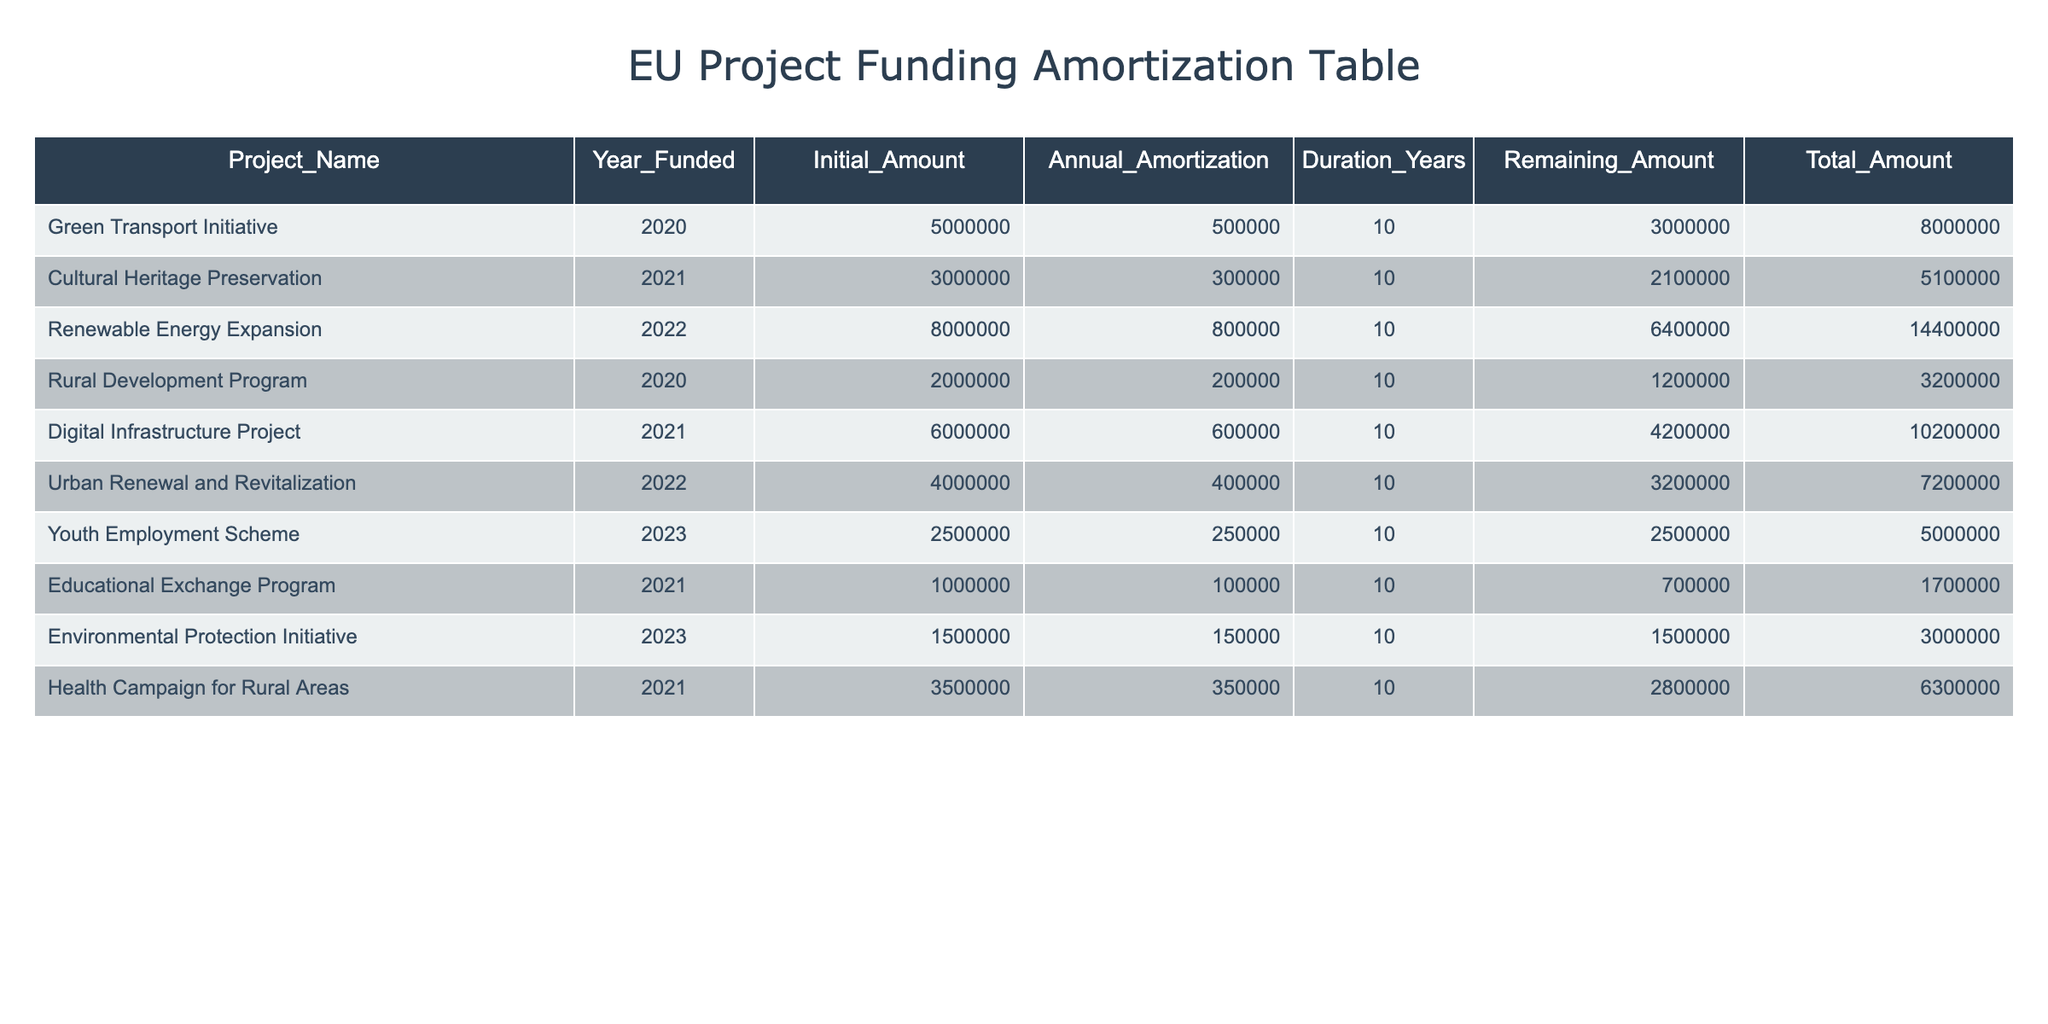What is the remaining amount for the Green Transport Initiative? The remaining amount for each project is listed in the "Remaining_Amount" column. For the Green Transport Initiative, this value is specified as 3000000.
Answer: 3000000 Which project has the highest initial amount? To determine the project with the highest initial amount, I will compare the values in the "Initial_Amount" column. The Renewable Energy Expansion has an initial amount of 8000000, which is higher than all other projects.
Answer: Renewable Energy Expansion How much total funding has been allocated for the Cultural Heritage Preservation? The total funding is calculated by adding the "Initial_Amount" and "Remaining_Amount" for the Cultural Heritage Preservation. The initial amount is 3000000, and the remaining amount is 2100000, so the total is 3000000 + 2100000 = 5100000.
Answer: 5100000 Is the Youth Employment Scheme fully amortized by the end of its duration? A project is fully amortized when the remaining amount is zero after the specified duration. The Youth Employment Scheme has a remaining amount of 2500000, which indicates that it has not yet been fully amortized by the end of its duration.
Answer: No What will be the remaining amount for the Rural Development Program after 5 years? To calculate the remaining amount after 5 years, I subtract the total amortized amount from the initial amount. The annual amortization is 200000, so after 5 years, the total amortization is 5 * 200000 = 1000000. The remaining amount is 1200000 - 1000000 = 200000.
Answer: 200000 How many projects have an annual amortization of 250000? I will look at the "Annual_Amortization" column to count projects with this value. Only the Youth Employment Scheme has an annual amortization of 250000.
Answer: 1 What is the average initial amount of the projects funded in 2021? The projects funded in 2021 are Cultural Heritage Preservation, Digital Infrastructure Project, and Health Campaign for Rural Areas, with initial amounts of 3000000, 6000000, and 3500000, respectively. Their total is 3000000 + 6000000 + 3500000 = 12500000. The average is 12500000 divided by 3, which equals approximately 4166666.67.
Answer: 4166666.67 Which project has the lowest remaining amount? To find this, I look at the "Remaining_Amount" column and identify the lowest value. The Educational Exchange Program has the lowest remaining amount of 700000.
Answer: Educational Exchange Program What is the total annual amortization for all projects combined? I will sum the "Annual_Amortization" values across all projects. The sum is 500000 + 300000 + 800000 + 200000 + 600000 + 400000 + 250000 + 100000 + 350000 + 150000 = 3350000.
Answer: 3350000 